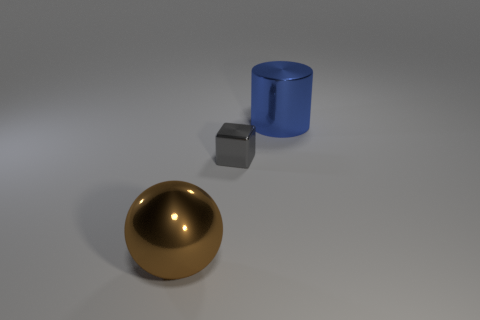Is there any other thing that has the same size as the metal block?
Offer a terse response. No. Are the cylinder and the large thing that is left of the large blue cylinder made of the same material?
Make the answer very short. Yes. What number of metallic objects are right of the big brown thing and in front of the cylinder?
Your answer should be compact. 1. The object that is the same size as the shiny ball is what shape?
Your answer should be compact. Cylinder. Are there any big brown metal things that are on the left side of the large object right of the large thing that is in front of the big blue shiny cylinder?
Give a very brief answer. Yes. There is a large cylinder; does it have the same color as the big shiny thing that is in front of the gray block?
Offer a terse response. No. How many big metallic spheres are the same color as the large cylinder?
Ensure brevity in your answer.  0. What number of objects are big shiny objects to the left of the large blue thing or blue balls?
Your response must be concise. 1. Is there a brown sphere of the same size as the blue metallic cylinder?
Keep it short and to the point. Yes. There is a big object in front of the large blue object; are there any blue metal cylinders on the right side of it?
Offer a very short reply. Yes. 